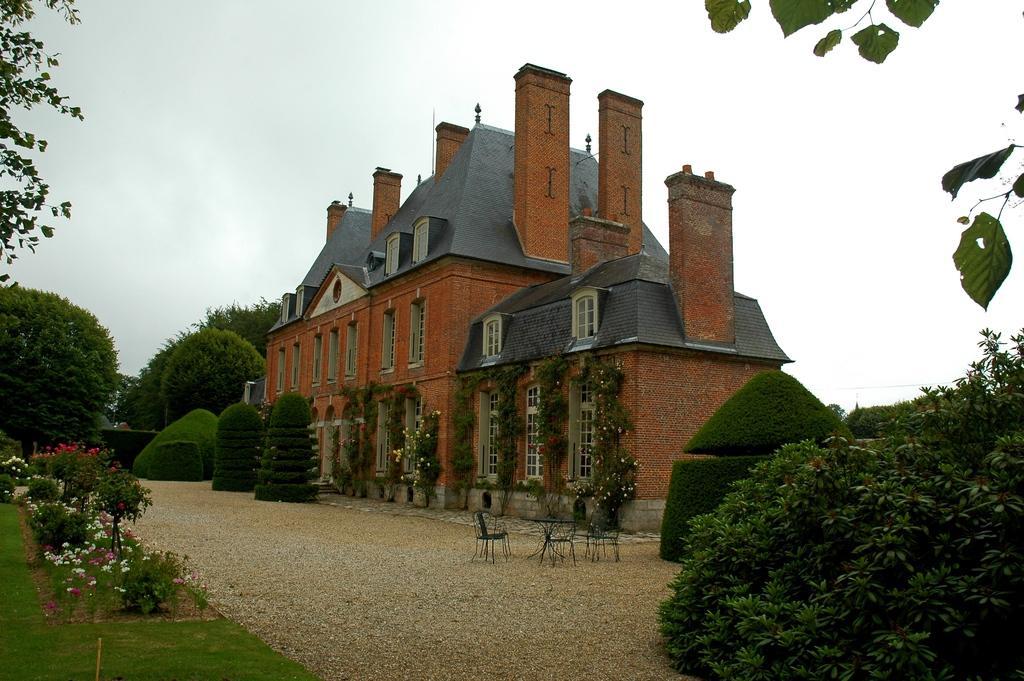Can you describe this image briefly? In this image I can see flowering plants, grass, chairs on the ground, building, windows, creepers and trees. In the background I can see the sky. This image is taken may be near the building. 